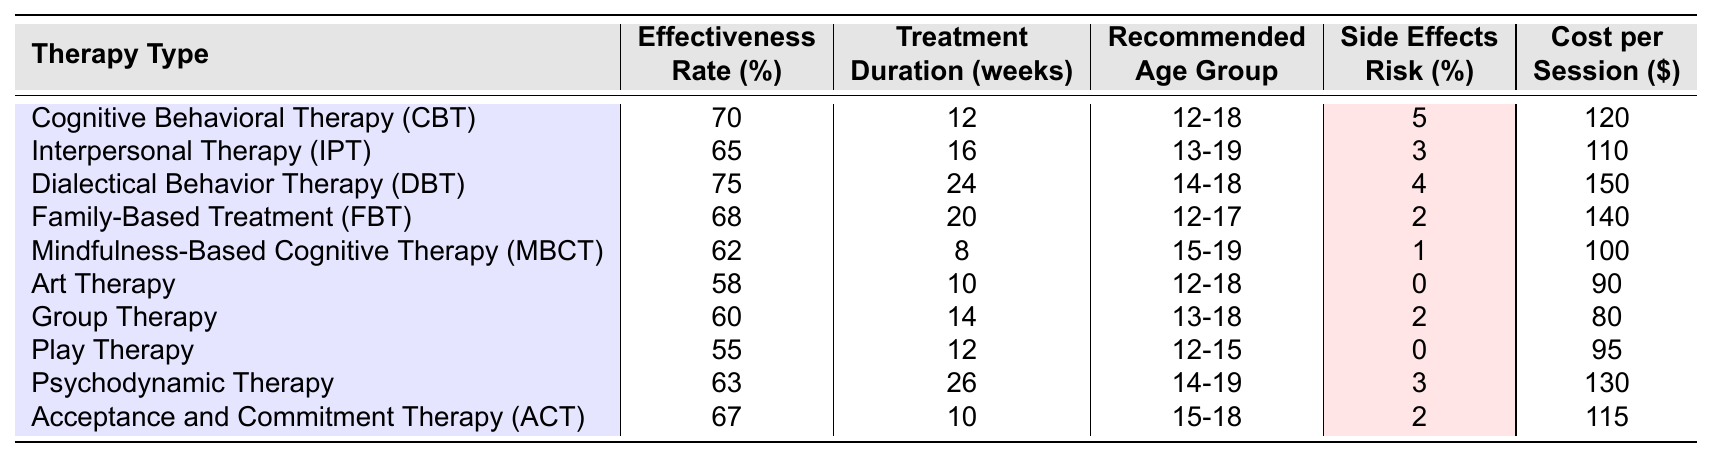What is the effectiveness rate of Dialectical Behavior Therapy (DBT)? The table shows that the effectiveness rate for DBT is listed as 75%.
Answer: 75% Which therapy has the highest effectiveness rate? According to the table, Dialectical Behavior Therapy (DBT) has the highest effectiveness rate at 75%.
Answer: DBT What is the treatment duration for Mindfulness-Based Cognitive Therapy (MBCT)? The table indicates that Mindfulness-Based Cognitive Therapy (MBCT) has a treatment duration of 8 weeks.
Answer: 8 weeks Is the side effects risk for Art Therapy 0%? From the table, it is stated that the side effects risk for Art Therapy is indeed 0%.
Answer: Yes What is the average cost per session for all the therapies listed? To find the average cost, sum the costs ($120 + $110 + $150 + $140 + $100 + $90 + $80 + $95 + $130 + $115 = $1,110), and then divide by the number of therapies (10). The average cost per session is $1,110 / 10 = $111.
Answer: $111 How many therapies have an effectiveness rate of 65% or more? By examining the table, the therapies with an effectiveness rate of 65% or more are CBT, DBT, IPT, FBT, and ACT. This gives a total of 5 therapies.
Answer: 5 What is the cost per session for the therapy with the least effectiveness rate? The therapy with the least effectiveness rate is Play Therapy, which costs $95 per session according to the table.
Answer: $95 Which therapy type has the lowest side effects risk? The table shows that Art Therapy and Play Therapy both have a side effects risk of 0%, which is the lowest of all listed therapies.
Answer: Art Therapy and Play Therapy How does the treatment duration of Family-Based Treatment (FBT) compare to that of Group Therapy? The treatment duration for FBT is 20 weeks and for Group Therapy is 14 weeks, so FBT has a longer treatment duration by 6 weeks.
Answer: FBT is longer by 6 weeks Which therapies are recommended for ages 12 to 15? The table indicates that the therapies recommended for ages 12 to 15 are Play Therapy.
Answer: Play Therapy 